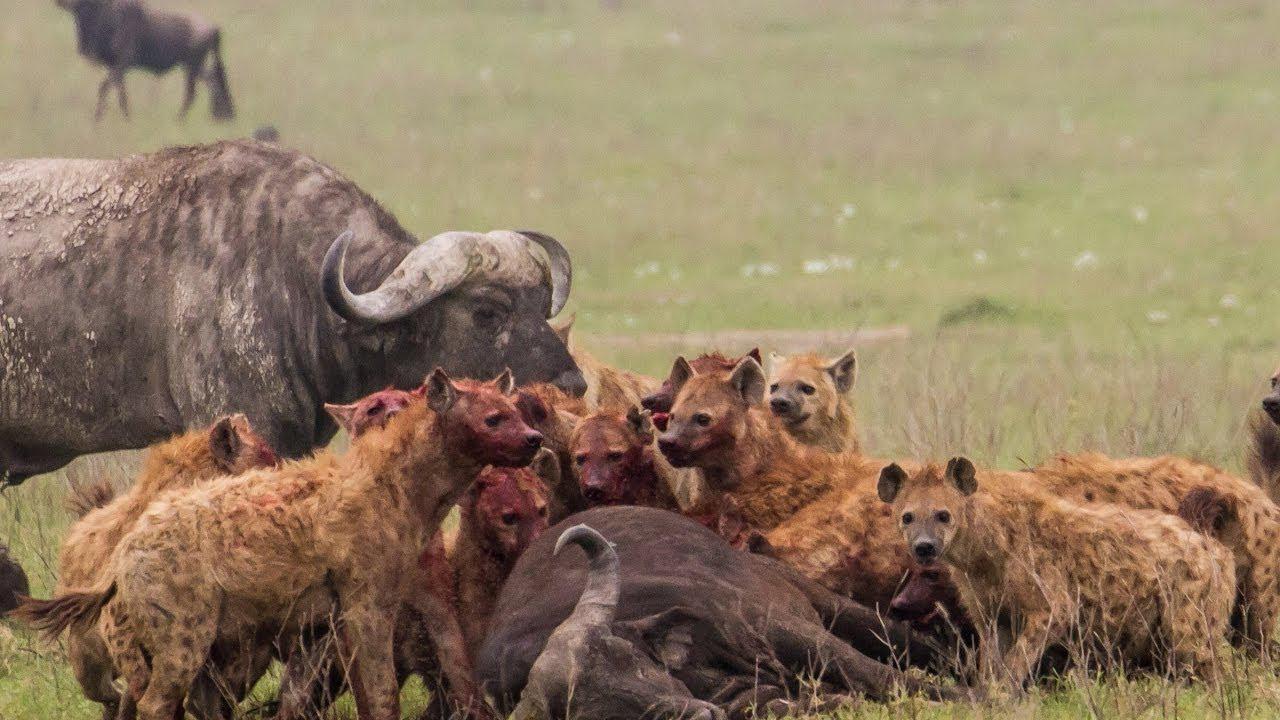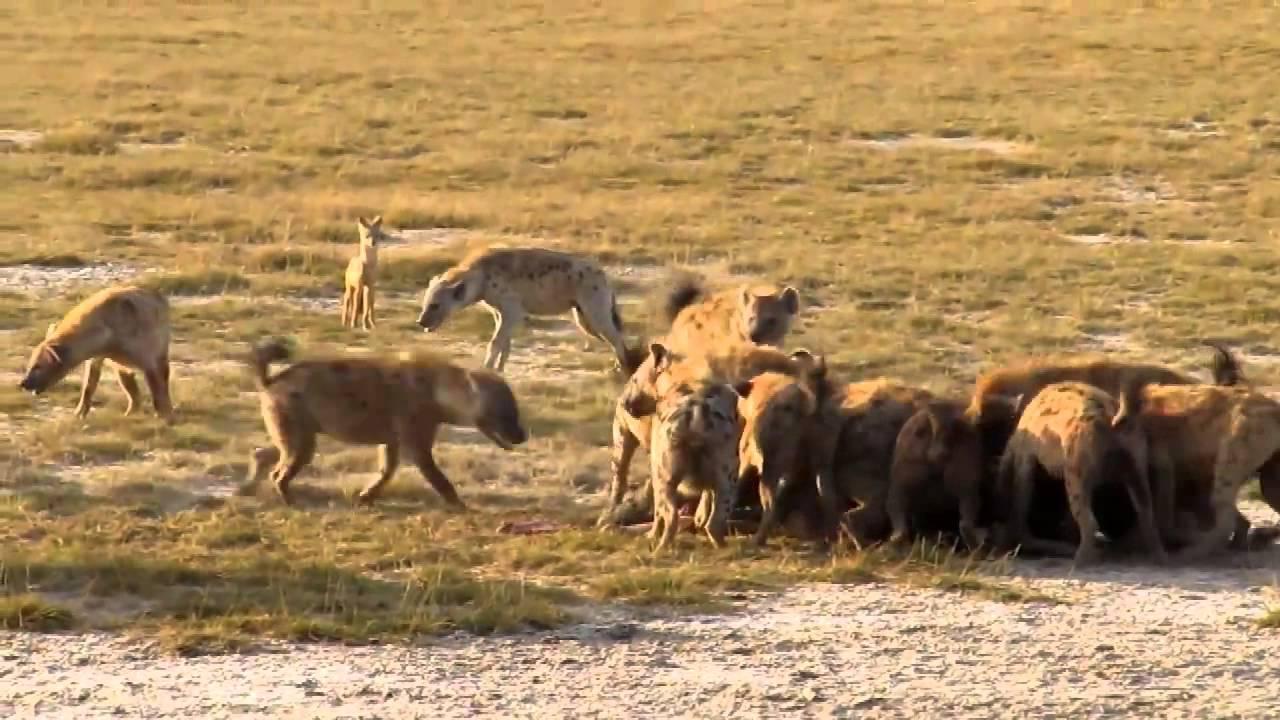The first image is the image on the left, the second image is the image on the right. For the images displayed, is the sentence "One image includes one standing water buffalo in the foreground near multiple hyenas, and the other image shows a pack of hyenas gathered around something on the ground." factually correct? Answer yes or no. Yes. 